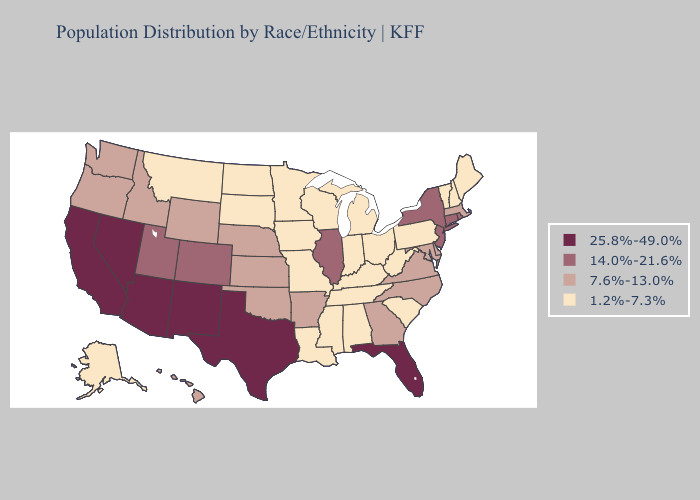Does the map have missing data?
Quick response, please. No. Does Illinois have the lowest value in the USA?
Give a very brief answer. No. Does Delaware have the highest value in the South?
Keep it brief. No. Does the map have missing data?
Give a very brief answer. No. Is the legend a continuous bar?
Give a very brief answer. No. Among the states that border Delaware , does New Jersey have the highest value?
Write a very short answer. Yes. Does Michigan have a lower value than Oregon?
Write a very short answer. Yes. Which states hav the highest value in the MidWest?
Give a very brief answer. Illinois. Name the states that have a value in the range 1.2%-7.3%?
Answer briefly. Alabama, Alaska, Indiana, Iowa, Kentucky, Louisiana, Maine, Michigan, Minnesota, Mississippi, Missouri, Montana, New Hampshire, North Dakota, Ohio, Pennsylvania, South Carolina, South Dakota, Tennessee, Vermont, West Virginia, Wisconsin. What is the value of Vermont?
Give a very brief answer. 1.2%-7.3%. Does the first symbol in the legend represent the smallest category?
Quick response, please. No. Among the states that border Massachusetts , does Connecticut have the highest value?
Give a very brief answer. Yes. Which states have the lowest value in the USA?
Short answer required. Alabama, Alaska, Indiana, Iowa, Kentucky, Louisiana, Maine, Michigan, Minnesota, Mississippi, Missouri, Montana, New Hampshire, North Dakota, Ohio, Pennsylvania, South Carolina, South Dakota, Tennessee, Vermont, West Virginia, Wisconsin. What is the value of Minnesota?
Concise answer only. 1.2%-7.3%. Among the states that border West Virginia , which have the lowest value?
Give a very brief answer. Kentucky, Ohio, Pennsylvania. 